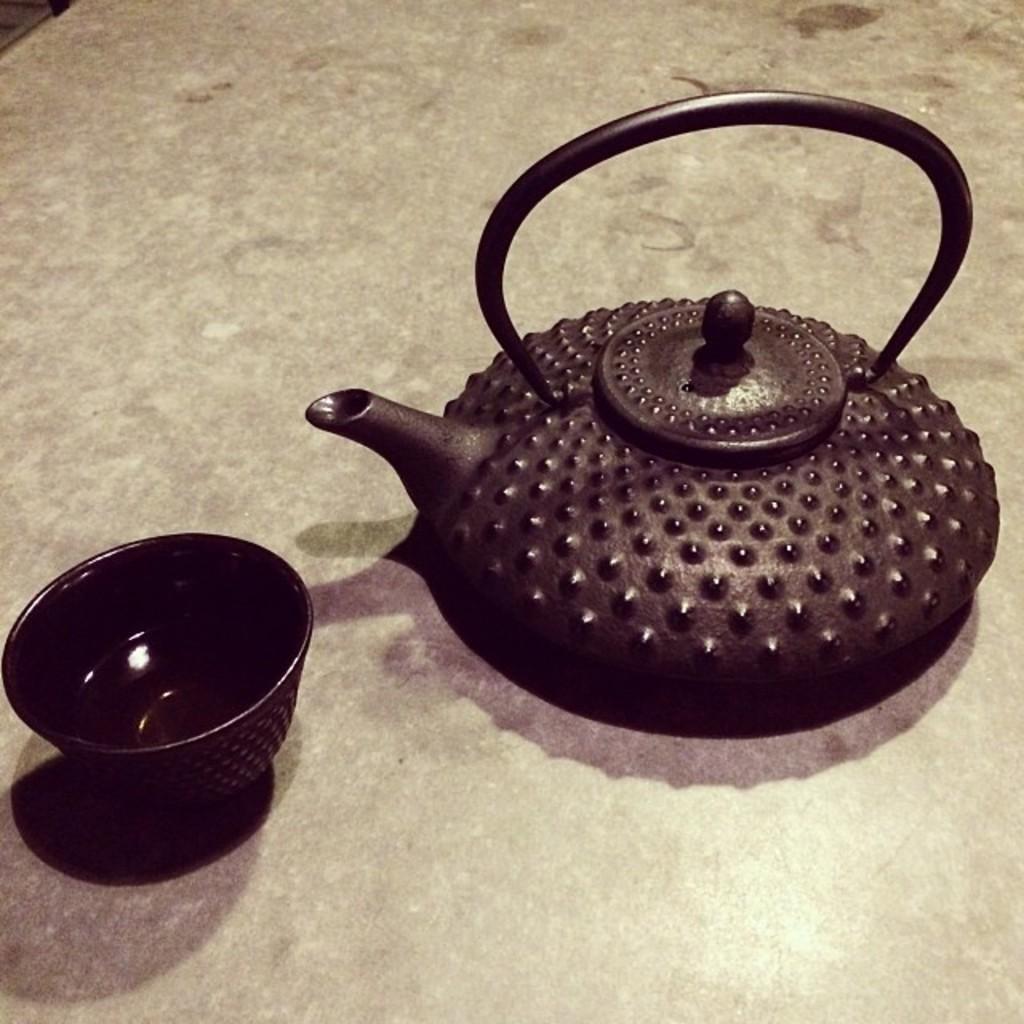In one or two sentences, can you explain what this image depicts? In this image we can see a teapot and a bowl which are placed on the surface. 